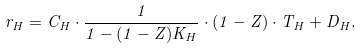<formula> <loc_0><loc_0><loc_500><loc_500>r _ { H } = C _ { H } \cdot \frac { 1 } { 1 - ( 1 - Z ) K _ { H } } \cdot ( 1 - Z ) \cdot T _ { H } + D _ { H } .</formula> 